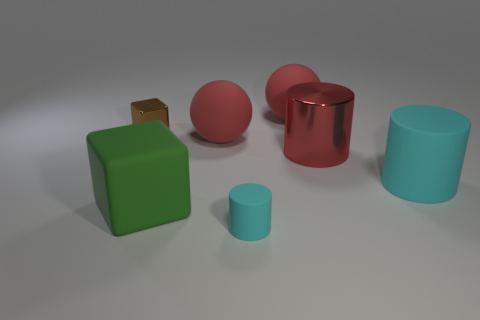The rubber object that is both in front of the big cyan thing and to the right of the big block is what color?
Ensure brevity in your answer.  Cyan. Are there fewer green matte objects that are in front of the small matte cylinder than matte balls behind the large rubber block?
Your answer should be very brief. Yes. How many other objects are the same shape as the large cyan matte object?
Offer a terse response. 2. What is the size of the cube that is made of the same material as the large cyan cylinder?
Give a very brief answer. Large. The shiny object right of the large matte ball that is left of the small cyan matte cylinder is what color?
Ensure brevity in your answer.  Red. Is the shape of the green object the same as the large red rubber thing in front of the metallic block?
Make the answer very short. No. What number of red shiny cylinders have the same size as the red shiny object?
Your answer should be compact. 0. There is a small object that is the same shape as the large green matte thing; what material is it?
Your response must be concise. Metal. Do the large cylinder that is behind the big cyan matte thing and the matte cylinder on the right side of the small cyan cylinder have the same color?
Your answer should be very brief. No. The cyan rubber object that is in front of the large cyan thing has what shape?
Make the answer very short. Cylinder. 